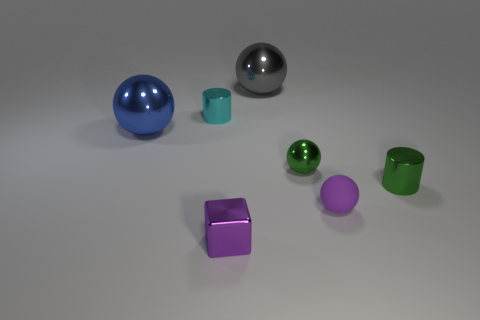Is there anything else that is the same material as the small purple sphere?
Provide a short and direct response. No. There is a purple metallic object; does it have the same size as the blue shiny object that is behind the purple rubber ball?
Offer a terse response. No. There is a matte sphere that is the same size as the green shiny ball; what is its color?
Give a very brief answer. Purple. The blue sphere is what size?
Provide a short and direct response. Large. Do the big sphere on the left side of the gray metallic object and the green sphere have the same material?
Give a very brief answer. Yes. Does the purple rubber thing have the same shape as the large blue shiny object?
Provide a succinct answer. Yes. There is a small cyan shiny object that is behind the shiny object that is in front of the green metallic object that is right of the small purple ball; what is its shape?
Provide a short and direct response. Cylinder. Do the small purple thing that is behind the tiny block and the small purple shiny thing in front of the gray metallic ball have the same shape?
Offer a very short reply. No. Are there any purple objects that have the same material as the big gray object?
Your response must be concise. Yes. There is a large metallic thing on the left side of the small metal cylinder to the left of the purple thing that is right of the gray ball; what color is it?
Your response must be concise. Blue. 